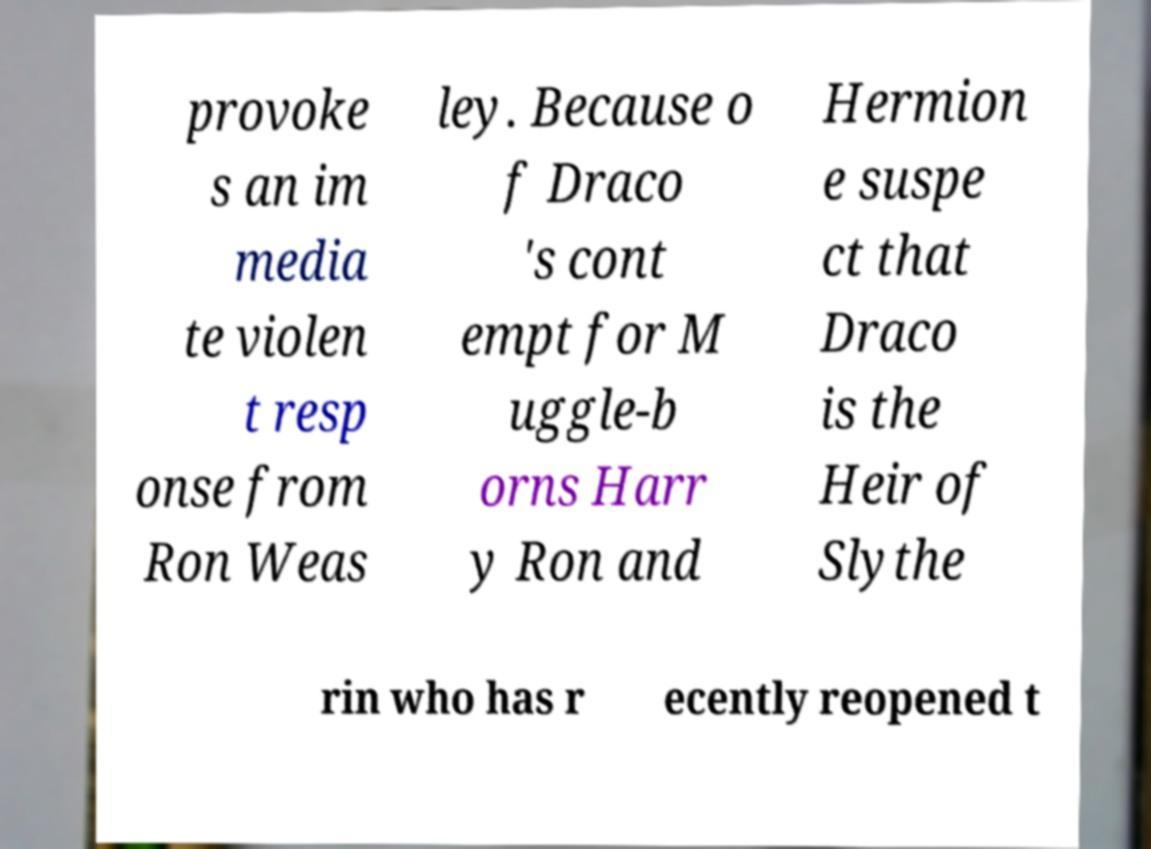Can you accurately transcribe the text from the provided image for me? provoke s an im media te violen t resp onse from Ron Weas ley. Because o f Draco 's cont empt for M uggle-b orns Harr y Ron and Hermion e suspe ct that Draco is the Heir of Slythe rin who has r ecently reopened t 